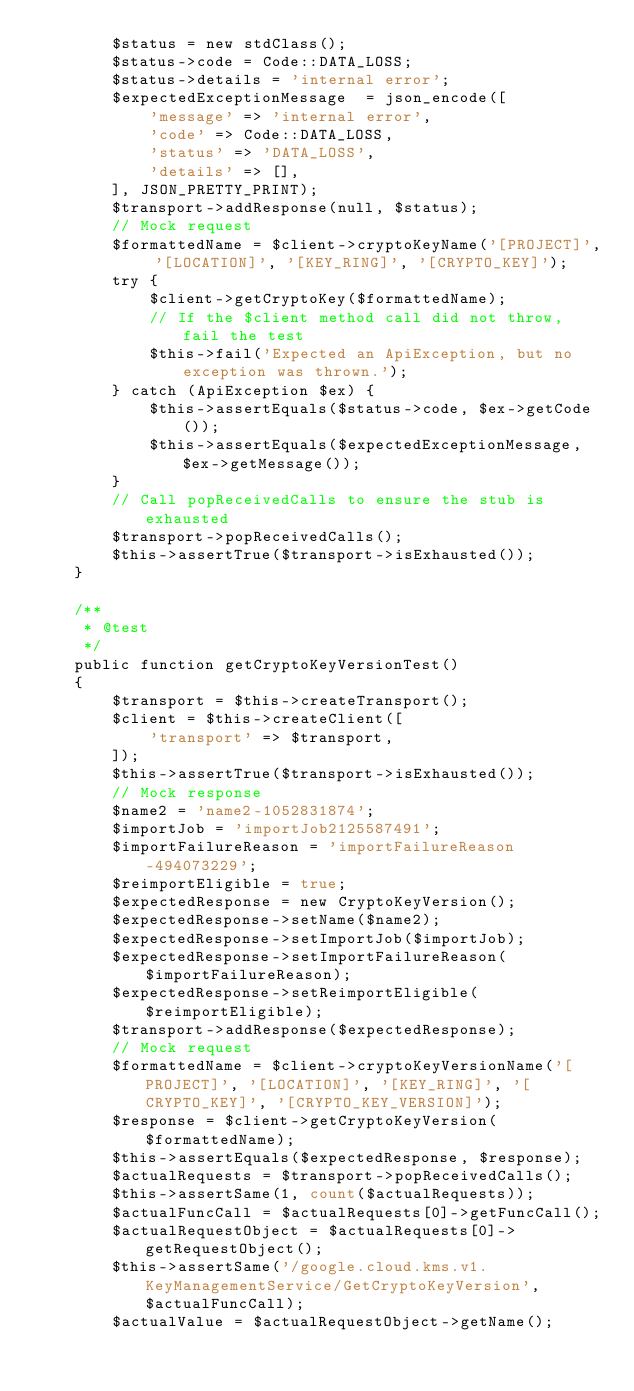<code> <loc_0><loc_0><loc_500><loc_500><_PHP_>        $status = new stdClass();
        $status->code = Code::DATA_LOSS;
        $status->details = 'internal error';
        $expectedExceptionMessage  = json_encode([
            'message' => 'internal error',
            'code' => Code::DATA_LOSS,
            'status' => 'DATA_LOSS',
            'details' => [],
        ], JSON_PRETTY_PRINT);
        $transport->addResponse(null, $status);
        // Mock request
        $formattedName = $client->cryptoKeyName('[PROJECT]', '[LOCATION]', '[KEY_RING]', '[CRYPTO_KEY]');
        try {
            $client->getCryptoKey($formattedName);
            // If the $client method call did not throw, fail the test
            $this->fail('Expected an ApiException, but no exception was thrown.');
        } catch (ApiException $ex) {
            $this->assertEquals($status->code, $ex->getCode());
            $this->assertEquals($expectedExceptionMessage, $ex->getMessage());
        }
        // Call popReceivedCalls to ensure the stub is exhausted
        $transport->popReceivedCalls();
        $this->assertTrue($transport->isExhausted());
    }

    /**
     * @test
     */
    public function getCryptoKeyVersionTest()
    {
        $transport = $this->createTransport();
        $client = $this->createClient([
            'transport' => $transport,
        ]);
        $this->assertTrue($transport->isExhausted());
        // Mock response
        $name2 = 'name2-1052831874';
        $importJob = 'importJob2125587491';
        $importFailureReason = 'importFailureReason-494073229';
        $reimportEligible = true;
        $expectedResponse = new CryptoKeyVersion();
        $expectedResponse->setName($name2);
        $expectedResponse->setImportJob($importJob);
        $expectedResponse->setImportFailureReason($importFailureReason);
        $expectedResponse->setReimportEligible($reimportEligible);
        $transport->addResponse($expectedResponse);
        // Mock request
        $formattedName = $client->cryptoKeyVersionName('[PROJECT]', '[LOCATION]', '[KEY_RING]', '[CRYPTO_KEY]', '[CRYPTO_KEY_VERSION]');
        $response = $client->getCryptoKeyVersion($formattedName);
        $this->assertEquals($expectedResponse, $response);
        $actualRequests = $transport->popReceivedCalls();
        $this->assertSame(1, count($actualRequests));
        $actualFuncCall = $actualRequests[0]->getFuncCall();
        $actualRequestObject = $actualRequests[0]->getRequestObject();
        $this->assertSame('/google.cloud.kms.v1.KeyManagementService/GetCryptoKeyVersion', $actualFuncCall);
        $actualValue = $actualRequestObject->getName();</code> 